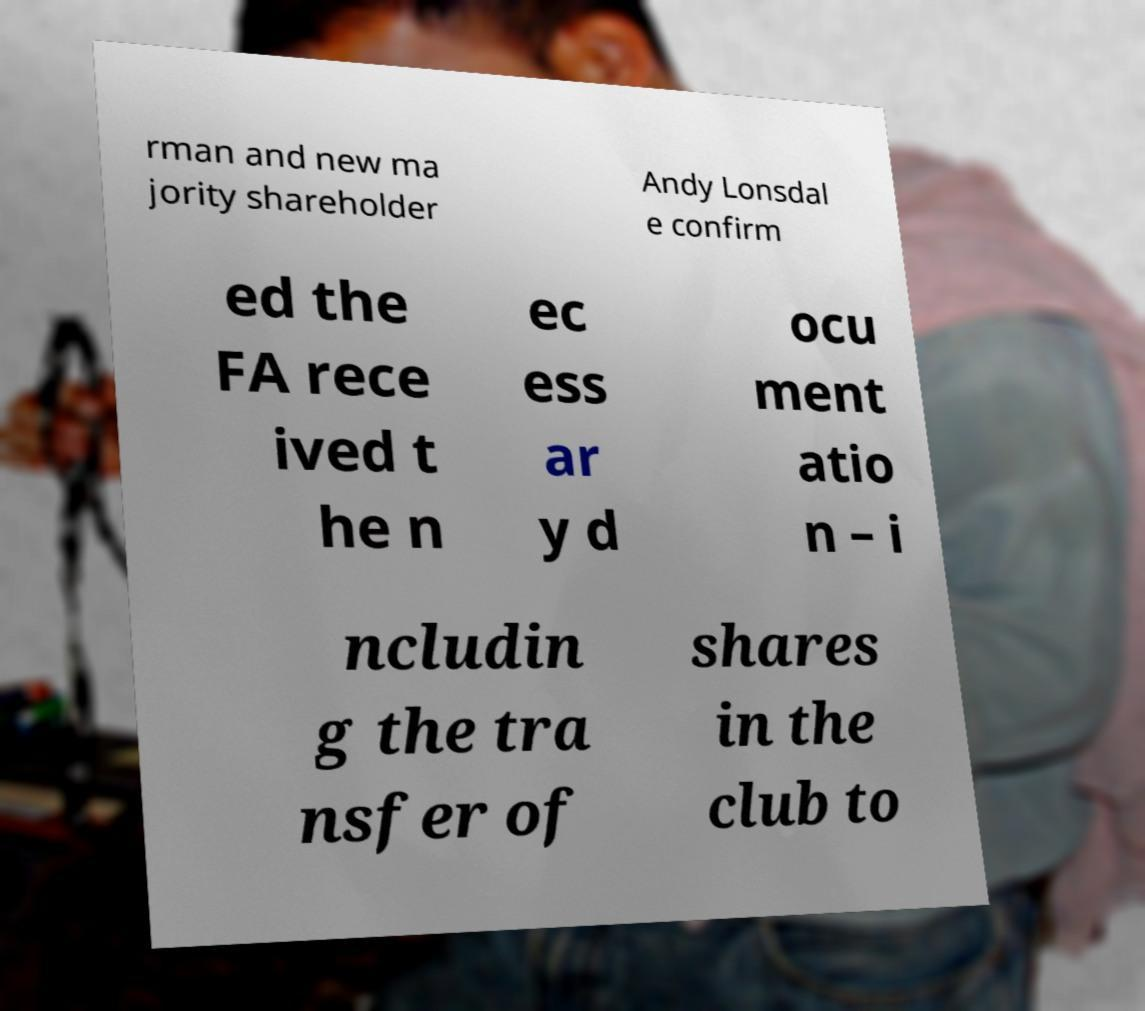Can you read and provide the text displayed in the image?This photo seems to have some interesting text. Can you extract and type it out for me? rman and new ma jority shareholder Andy Lonsdal e confirm ed the FA rece ived t he n ec ess ar y d ocu ment atio n – i ncludin g the tra nsfer of shares in the club to 